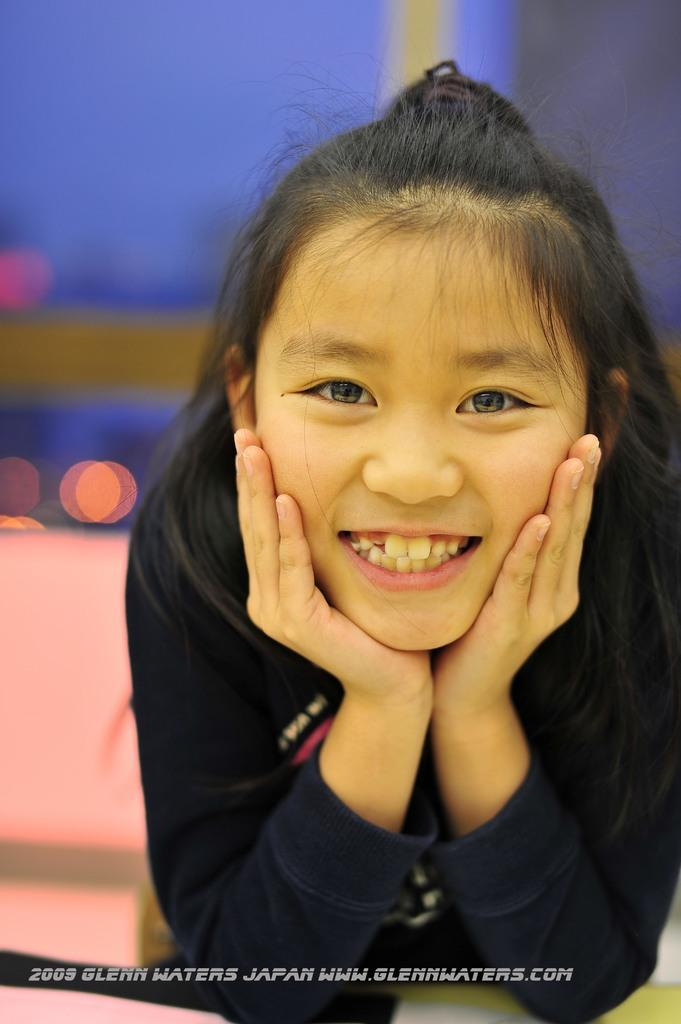What is the main subject of the picture? The main subject of the picture is a girl. Can you describe the girl's expression in the picture? The girl has a pretty smile on her face. What type of rat can be seen in the picture? There is no rat present in the picture; it features a girl with a pretty smile on her face. What news is being reported in the picture? There is no news being reported in the picture; it features a girl with a pretty smile on her face. 